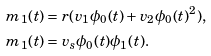Convert formula to latex. <formula><loc_0><loc_0><loc_500><loc_500>m _ { 1 } ( t ) & = r ( v _ { 1 } \phi _ { 0 } ( t ) + v _ { 2 } \phi _ { 0 } ( t ) ^ { 2 } ) , \\ m _ { 1 } ( t ) & = v _ { s } \phi _ { 0 } ( t ) \phi _ { 1 } ( t ) .</formula> 